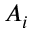<formula> <loc_0><loc_0><loc_500><loc_500>A _ { i }</formula> 